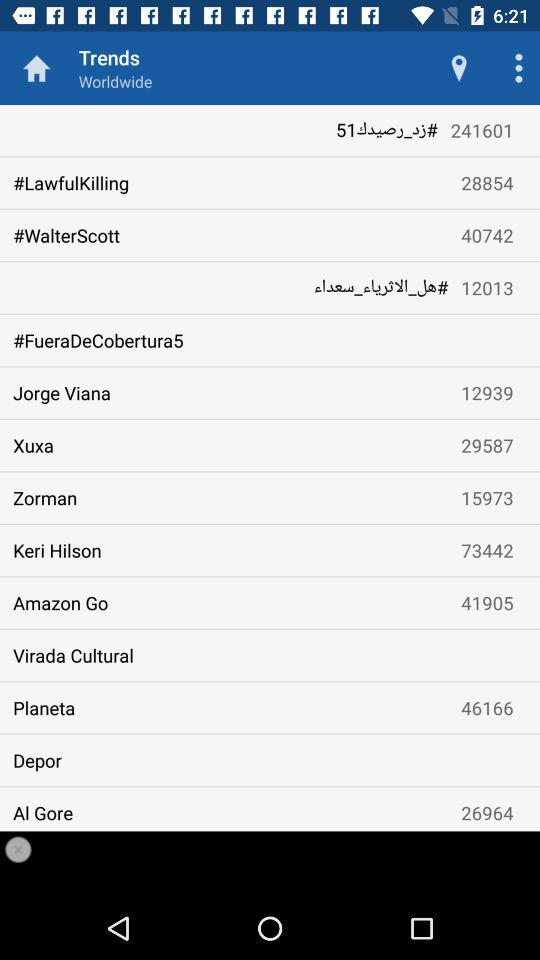How many hashtags are associated with "Zorman"? There are 15973 hashtags associated with "Zorman". 